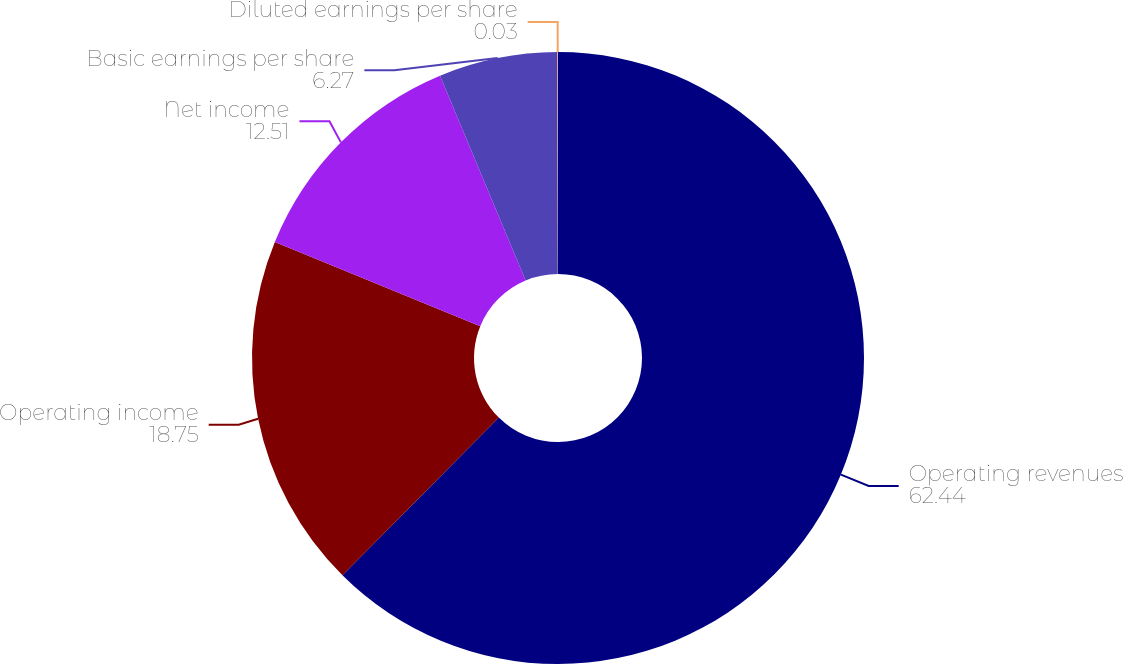Convert chart. <chart><loc_0><loc_0><loc_500><loc_500><pie_chart><fcel>Operating revenues<fcel>Operating income<fcel>Net income<fcel>Basic earnings per share<fcel>Diluted earnings per share<nl><fcel>62.44%<fcel>18.75%<fcel>12.51%<fcel>6.27%<fcel>0.03%<nl></chart> 